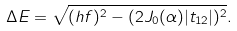Convert formula to latex. <formula><loc_0><loc_0><loc_500><loc_500>\Delta E = \sqrt { ( h f ) ^ { 2 } - ( 2 J _ { 0 } ( \alpha ) | t _ { 1 2 } | ) ^ { 2 } } .</formula> 